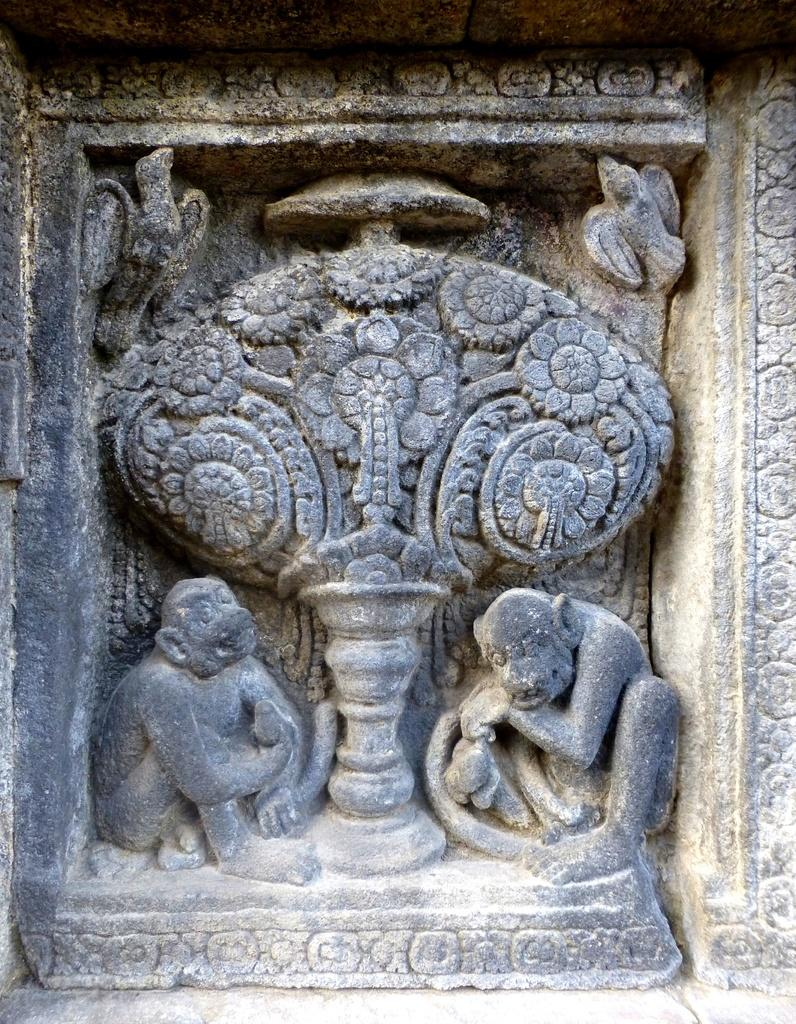What is the main subject of the image? The main subject of the image is a carved stone. What type of jeans is the person wearing while showing interest in the carved stone? There is no person present in the image, and therefore no jeans or indication of interest can be observed. 